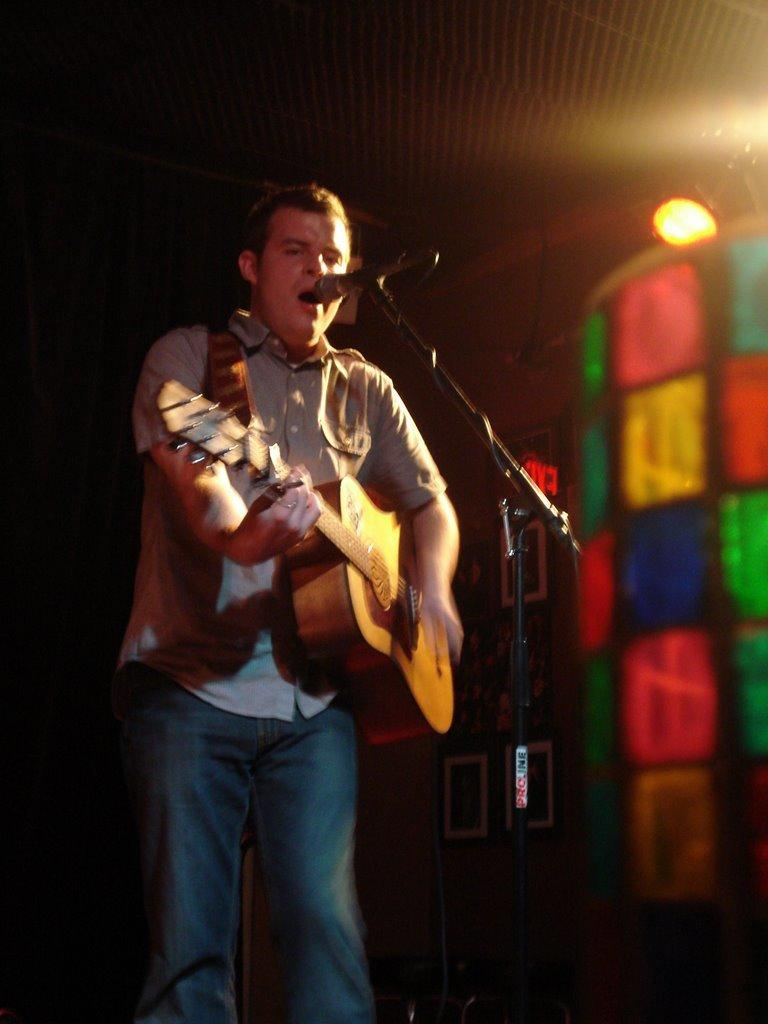What is the man in the image doing? The man is playing the guitar and singing. What object is in front of the man? There is a microphone in front of the man. Can you describe the lighting in the image? There is light visible at the top of the image. What type of drug can be seen in the image? There is no drug present in the image. Can you describe the window in the image? There is no window present in the image. 